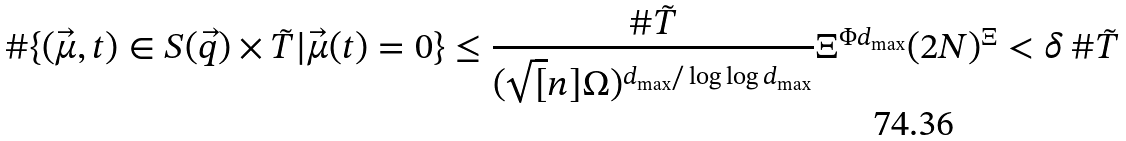<formula> <loc_0><loc_0><loc_500><loc_500>\# \{ ( \vec { \mu } , t ) \in S ( \vec { q } ) \times \tilde { T } | \vec { \mu } ( t ) = 0 \} & \leq \frac { \# \tilde { T } } { ( \sqrt { [ } n ] { \Omega } ) ^ { d _ { \max } / \log \log d _ { \max } } } \Xi ^ { \Phi d _ { \max } } ( 2 N ) ^ { \Xi } < \delta \, \# \tilde { T }</formula> 